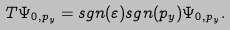Convert formula to latex. <formula><loc_0><loc_0><loc_500><loc_500>T { \Psi } _ { 0 , p _ { y } } = s g n ( \varepsilon ) s g n ( p _ { y } ) { \Psi } _ { 0 , p _ { y } } .</formula> 